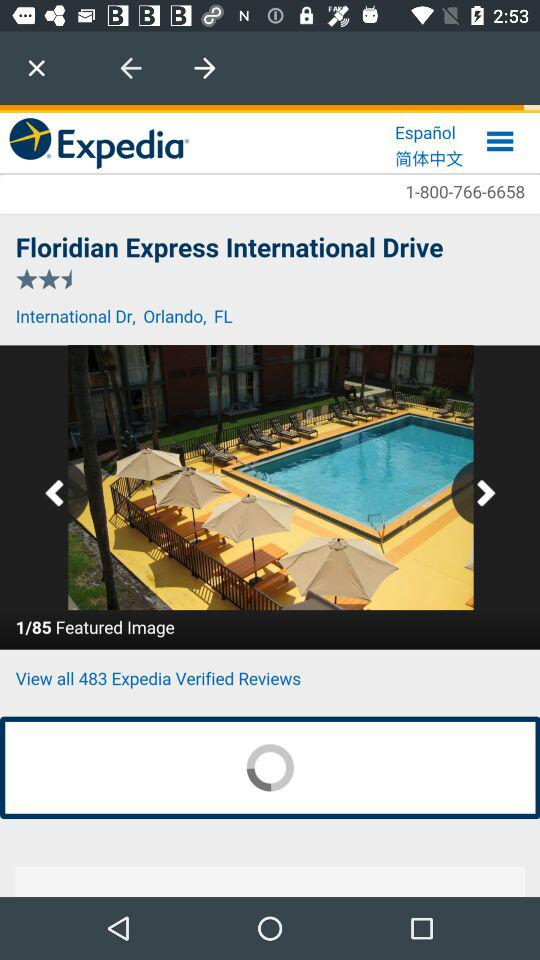What is the name of the hotel? The name of the hotel is "Floridian Express International Drive". 